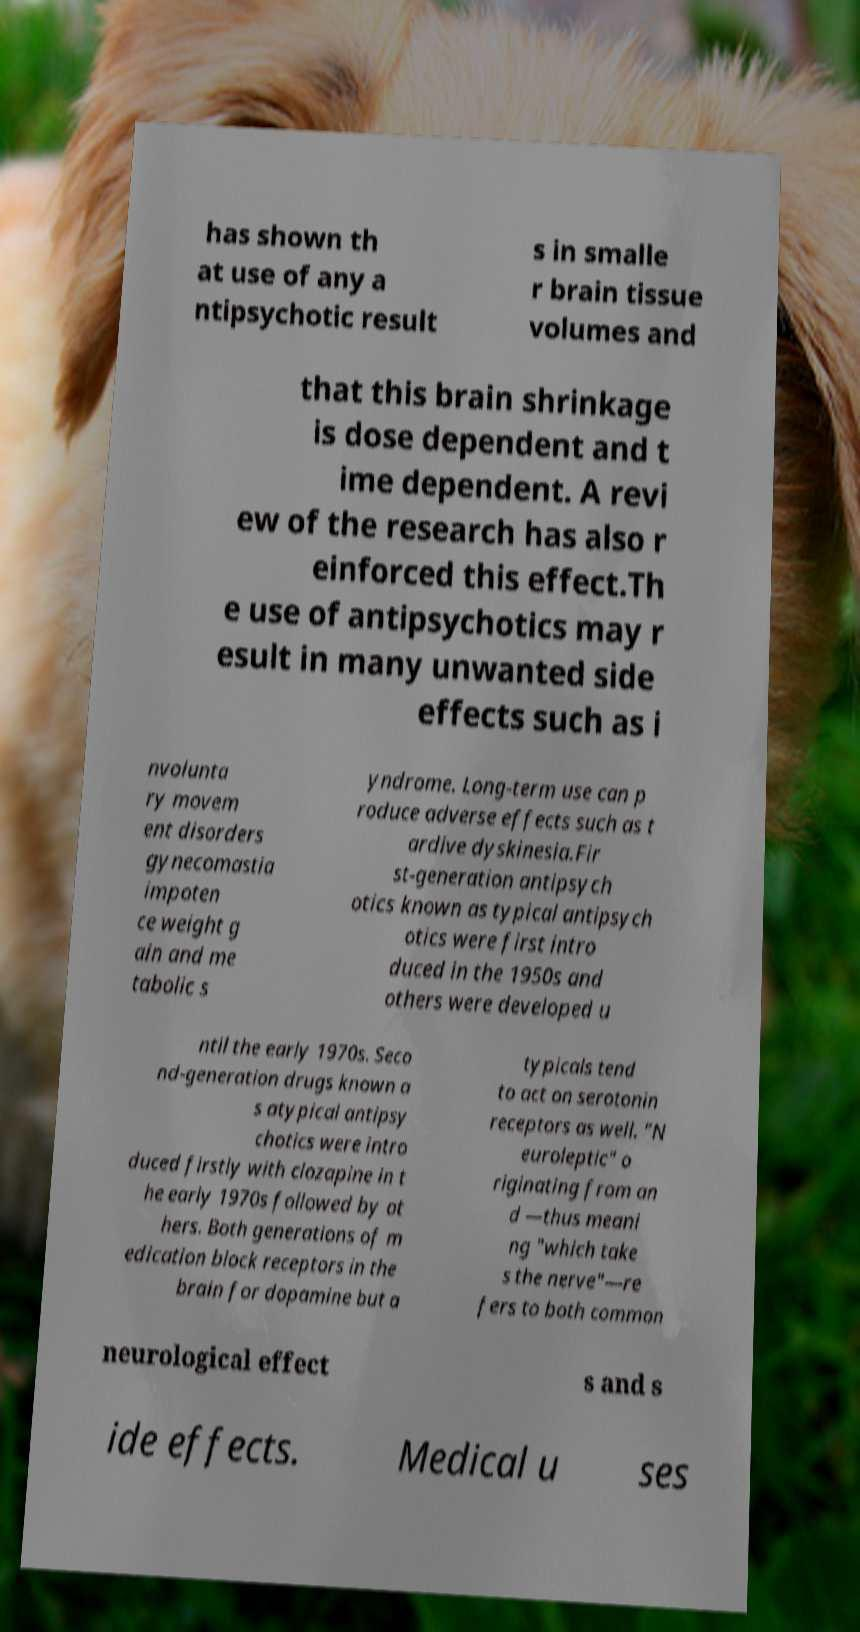There's text embedded in this image that I need extracted. Can you transcribe it verbatim? has shown th at use of any a ntipsychotic result s in smalle r brain tissue volumes and that this brain shrinkage is dose dependent and t ime dependent. A revi ew of the research has also r einforced this effect.Th e use of antipsychotics may r esult in many unwanted side effects such as i nvolunta ry movem ent disorders gynecomastia impoten ce weight g ain and me tabolic s yndrome. Long-term use can p roduce adverse effects such as t ardive dyskinesia.Fir st-generation antipsych otics known as typical antipsych otics were first intro duced in the 1950s and others were developed u ntil the early 1970s. Seco nd-generation drugs known a s atypical antipsy chotics were intro duced firstly with clozapine in t he early 1970s followed by ot hers. Both generations of m edication block receptors in the brain for dopamine but a typicals tend to act on serotonin receptors as well. "N euroleptic" o riginating from an d —thus meani ng "which take s the nerve"—re fers to both common neurological effect s and s ide effects. Medical u ses 